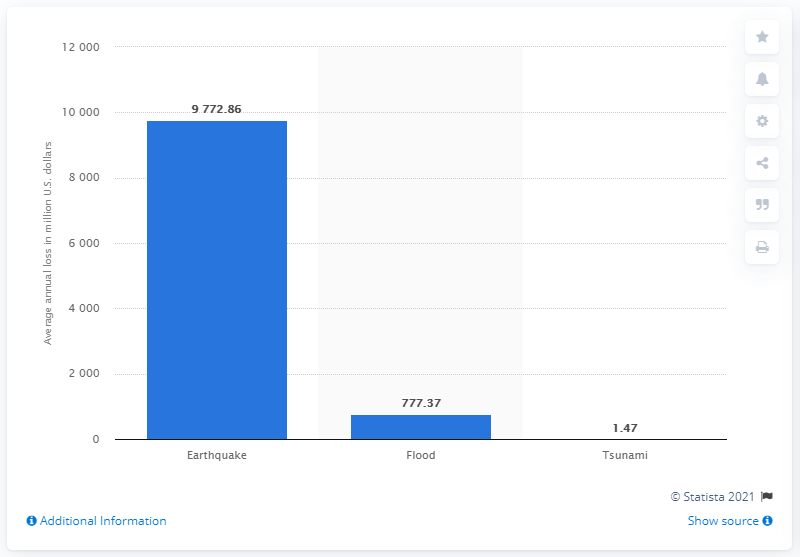Point out several critical features in this image. In 2015, it is estimated that Italy suffered a significant loss due to earthquakes, amounting to approximately 9,772.86. The estimated value of Italy's flooding losses was approximately 777.37. 